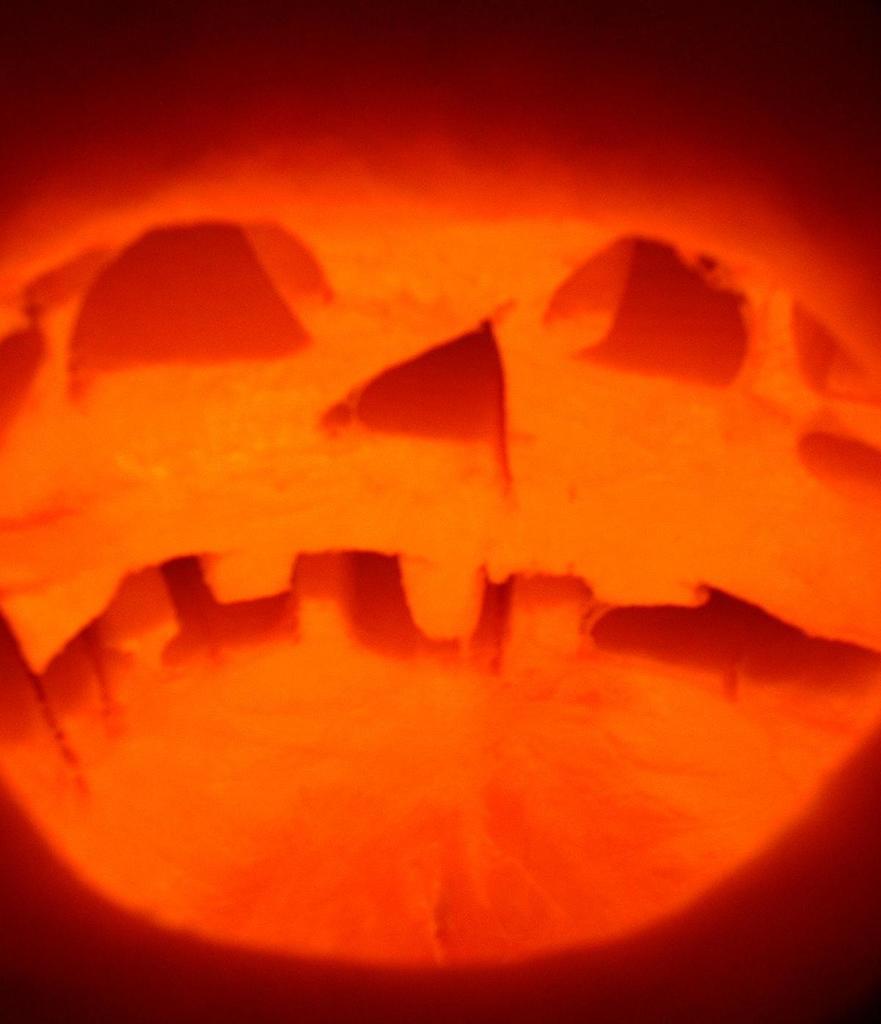Can you describe this image briefly? In this image I can see an orange colour thing. 